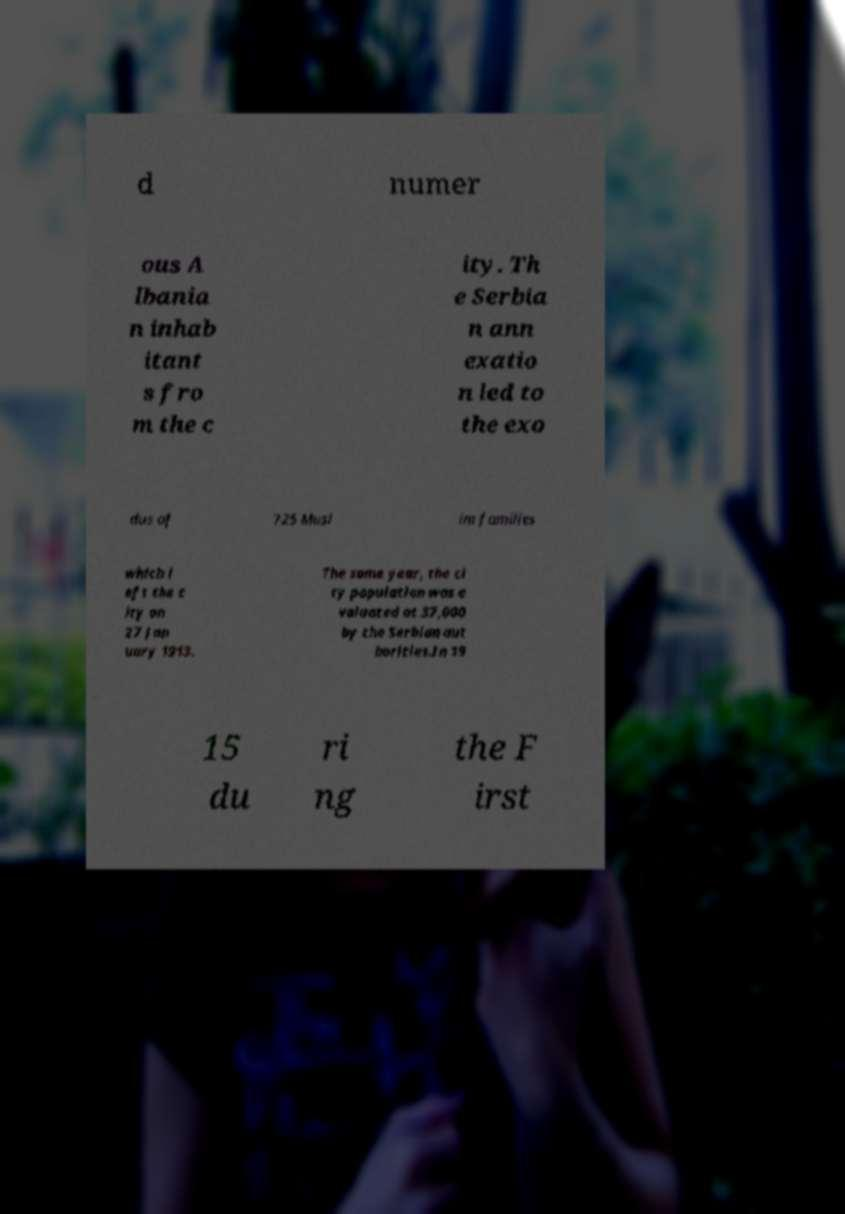Can you read and provide the text displayed in the image?This photo seems to have some interesting text. Can you extract and type it out for me? d numer ous A lbania n inhab itant s fro m the c ity. Th e Serbia n ann exatio n led to the exo dus of 725 Musl im families which l eft the c ity on 27 Jan uary 1913. The same year, the ci ty population was e valuated at 37,000 by the Serbian aut horities.In 19 15 du ri ng the F irst 